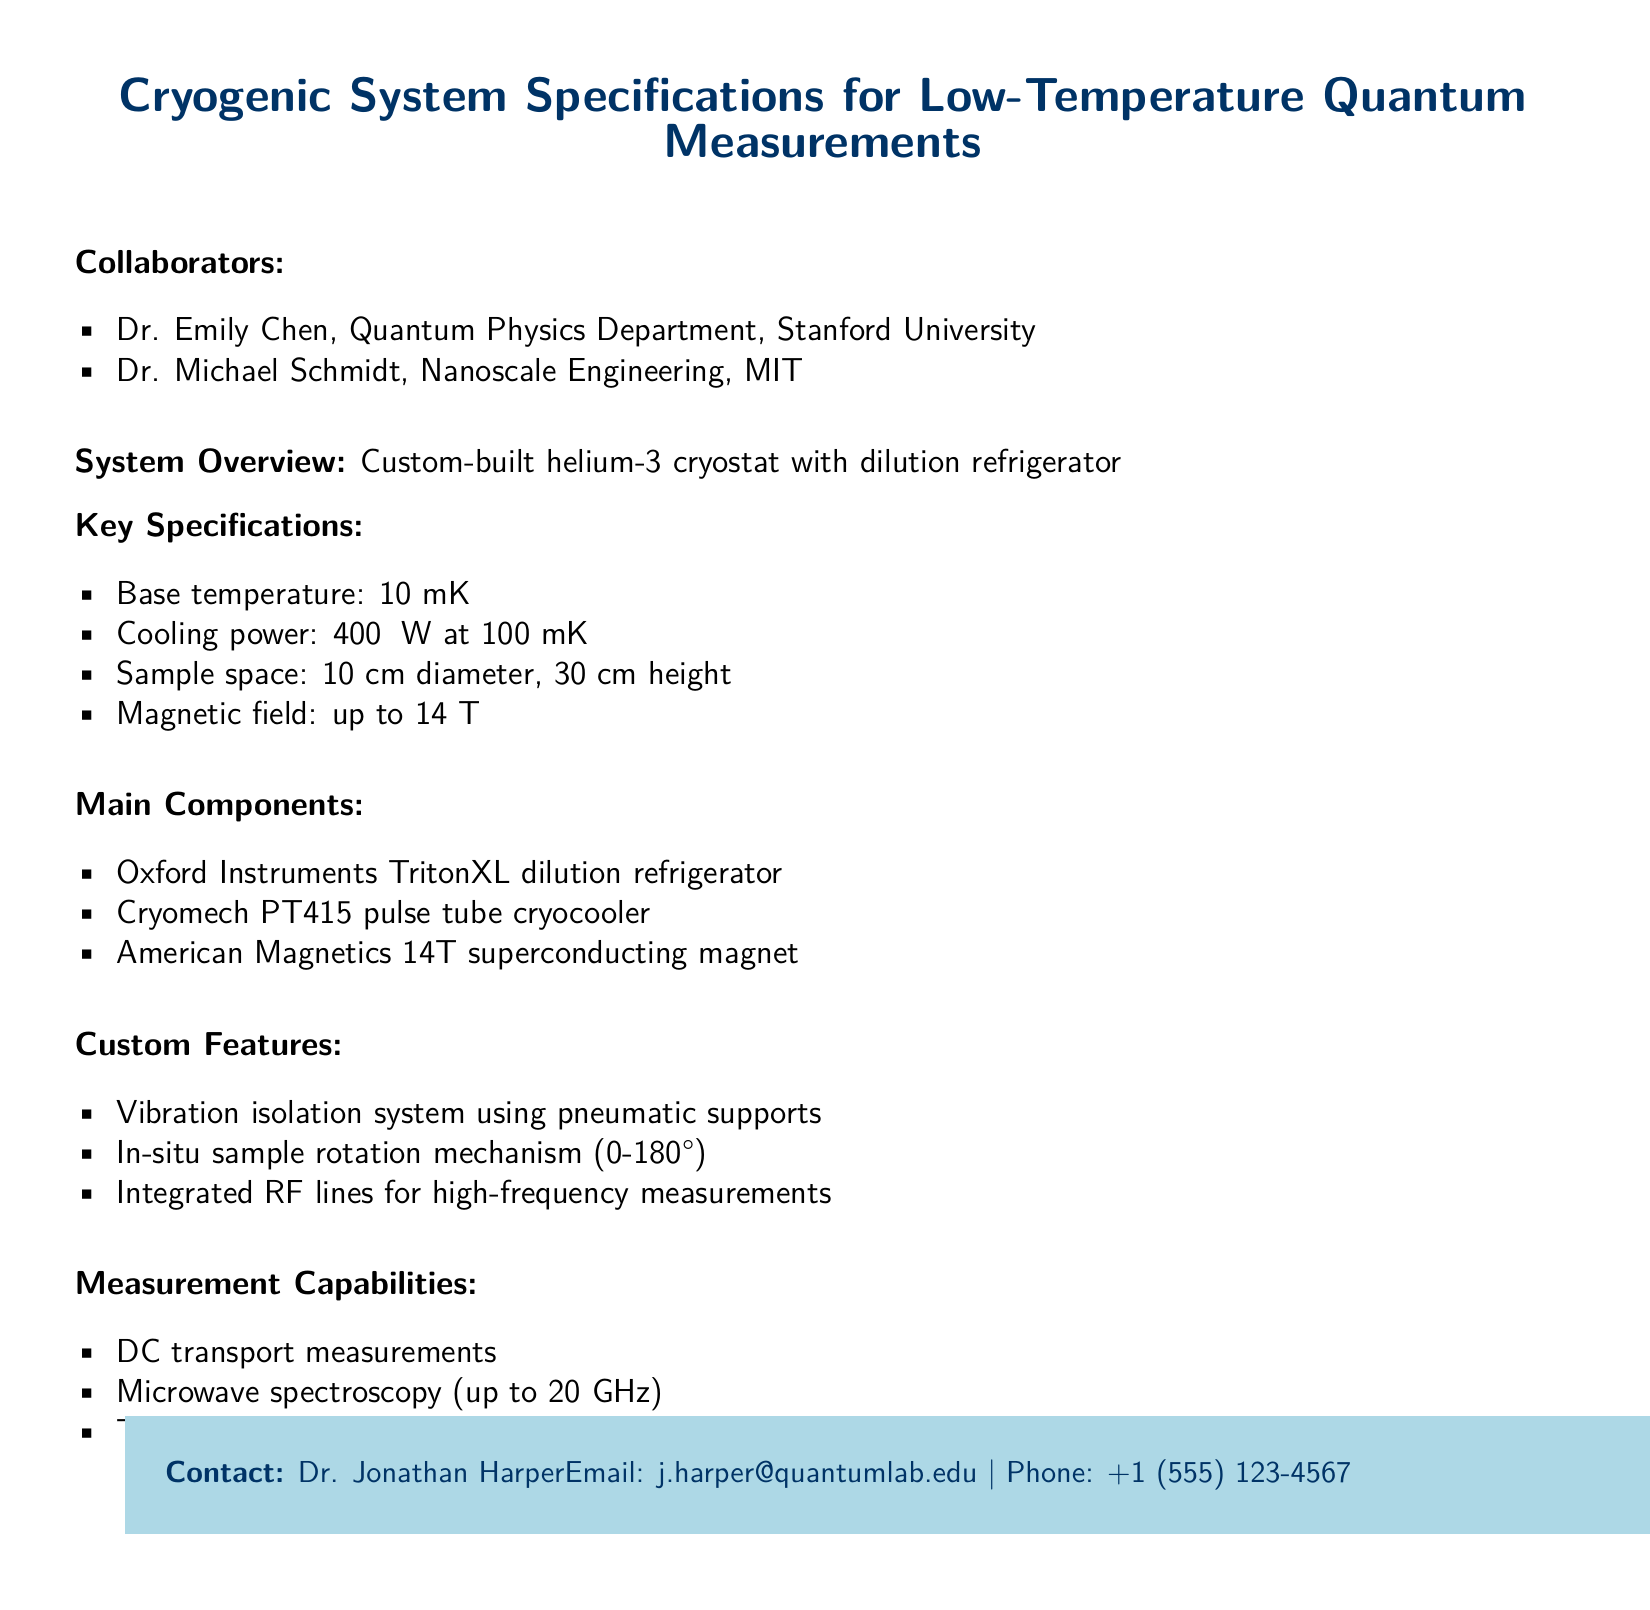What is the base temperature of the cryogenic system? The base temperature is listed in the key specifications section of the document.
Answer: 10 mK Who are the collaborators on this project? The collaborators are mentioned in the overview of the document, specifically in the collaborators section.
Answer: Dr. Emily Chen, Dr. Michael Schmidt What is the cooling power provided by the system? The cooling power specification is provided in the key specifications section.
Answer: 400 μW at 100 mK What is the maximum magnetic field supported by the system? The maximum magnetic field is indicated in the key specifications part of the document.
Answer: 14 T What is a custom feature of the cryogenic system? The document lists several custom features; one can be picked to answer the question.
Answer: Vibration isolation system How tall is the sample space of the cryogenic system? The sample space height is specified in the key specifications section.
Answer: 30 cm What type of measurements can be performed with this system? The document outlines the measurement capabilities, which directly answer this question.
Answer: DC transport measurements What is the name of the dilution refrigerator mentioned? The name of the dilution refrigerator is provided in the main components section.
Answer: Oxford Instruments TritonXL What is the email address of the contact person? The email address is provided in the contact section at the bottom of the document.
Answer: j.harper@quantumlab.edu 